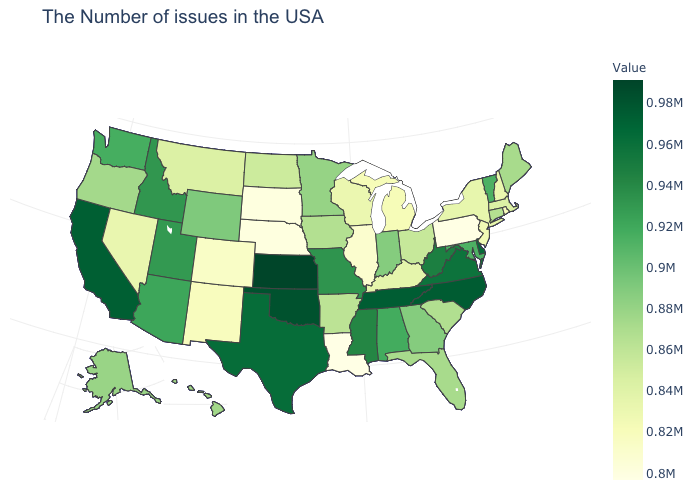Is the legend a continuous bar?
Write a very short answer. Yes. Which states hav the highest value in the Northeast?
Be succinct. Vermont. 